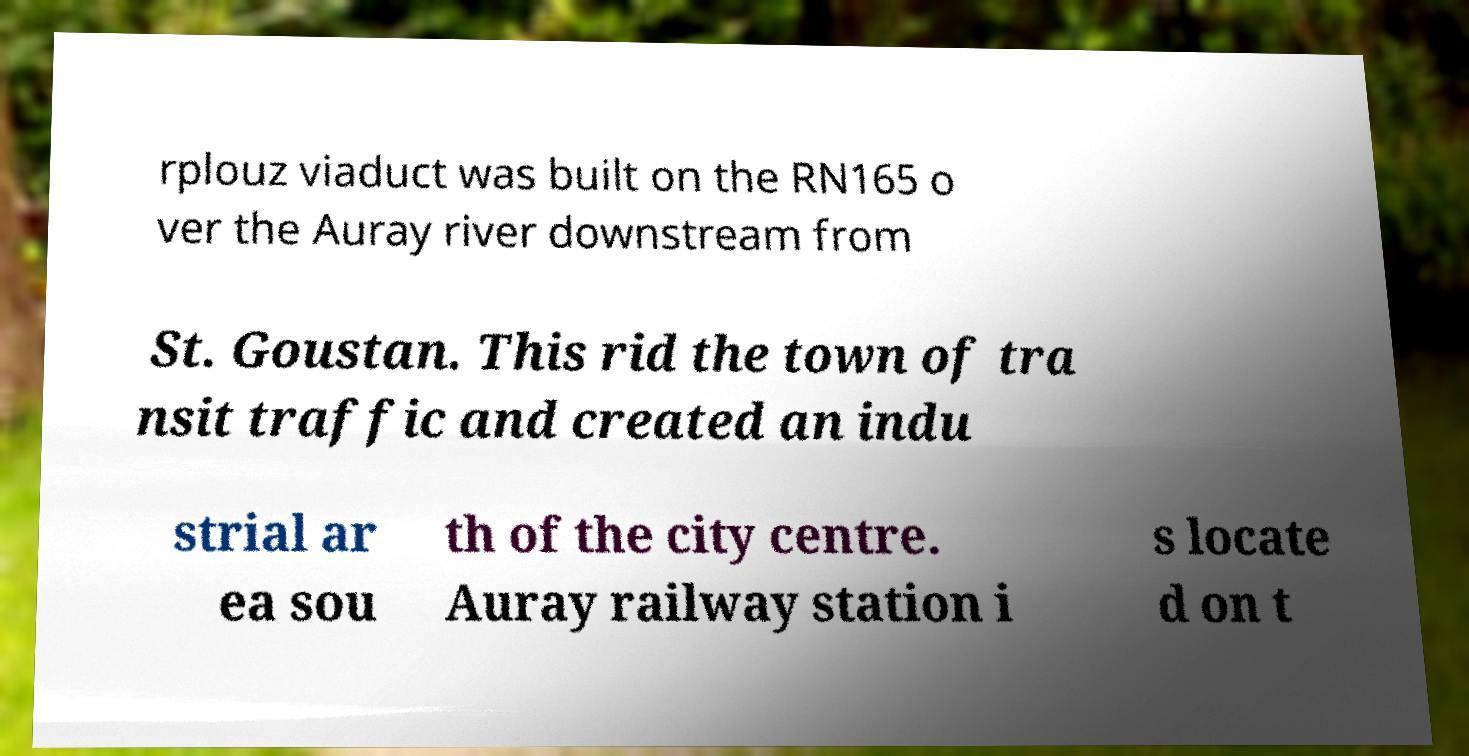Can you accurately transcribe the text from the provided image for me? rplouz viaduct was built on the RN165 o ver the Auray river downstream from St. Goustan. This rid the town of tra nsit traffic and created an indu strial ar ea sou th of the city centre. Auray railway station i s locate d on t 